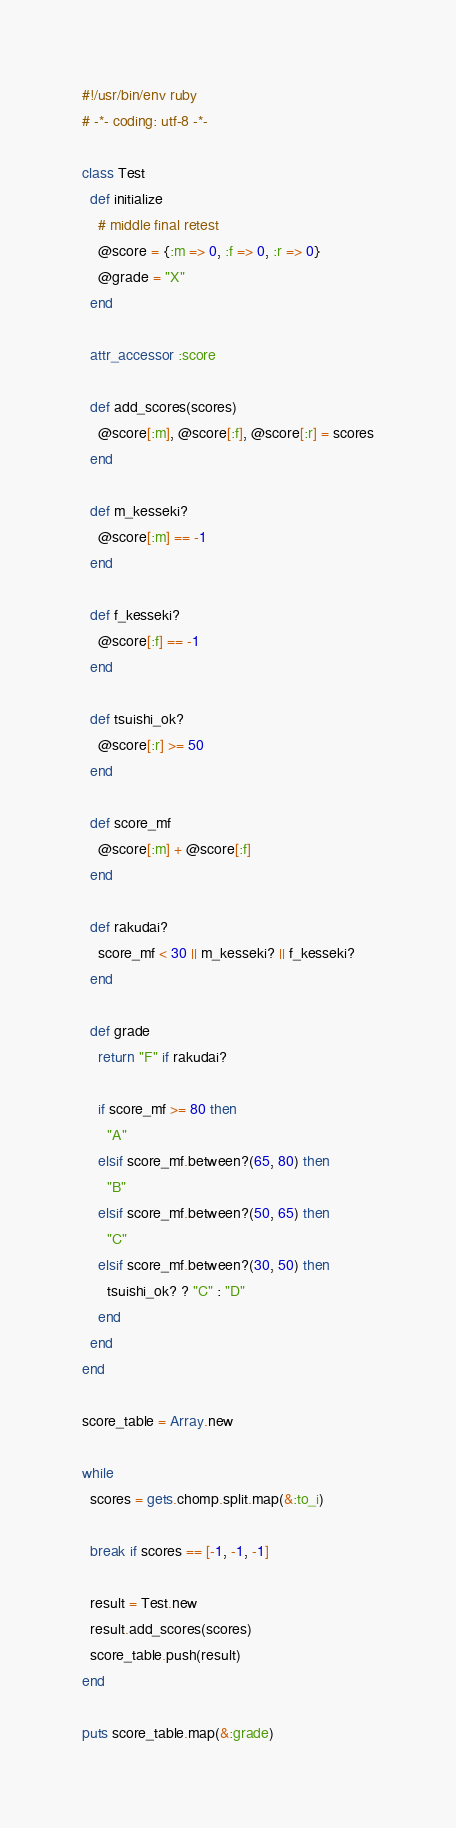<code> <loc_0><loc_0><loc_500><loc_500><_Ruby_>#!/usr/bin/env ruby
# -*- coding: utf-8 -*-

class Test
  def initialize
    # middle final retest
    @score = {:m => 0, :f => 0, :r => 0}
    @grade = "X"
  end

  attr_accessor :score

  def add_scores(scores)
    @score[:m], @score[:f], @score[:r] = scores
  end

  def m_kesseki?
    @score[:m] == -1
  end

  def f_kesseki?
    @score[:f] == -1
  end

  def tsuishi_ok?
    @score[:r] >= 50
  end

  def score_mf
    @score[:m] + @score[:f]
  end

  def rakudai?
    score_mf < 30 || m_kesseki? || f_kesseki?
  end

  def grade
    return "F" if rakudai?

    if score_mf >= 80 then
      "A"
    elsif score_mf.between?(65, 80) then
      "B"
    elsif score_mf.between?(50, 65) then
      "C"
    elsif score_mf.between?(30, 50) then
      tsuishi_ok? ? "C" : "D"
    end
  end
end

score_table = Array.new

while
  scores = gets.chomp.split.map(&:to_i)

  break if scores == [-1, -1, -1]

  result = Test.new
  result.add_scores(scores)
  score_table.push(result)
end

puts score_table.map(&:grade)</code> 